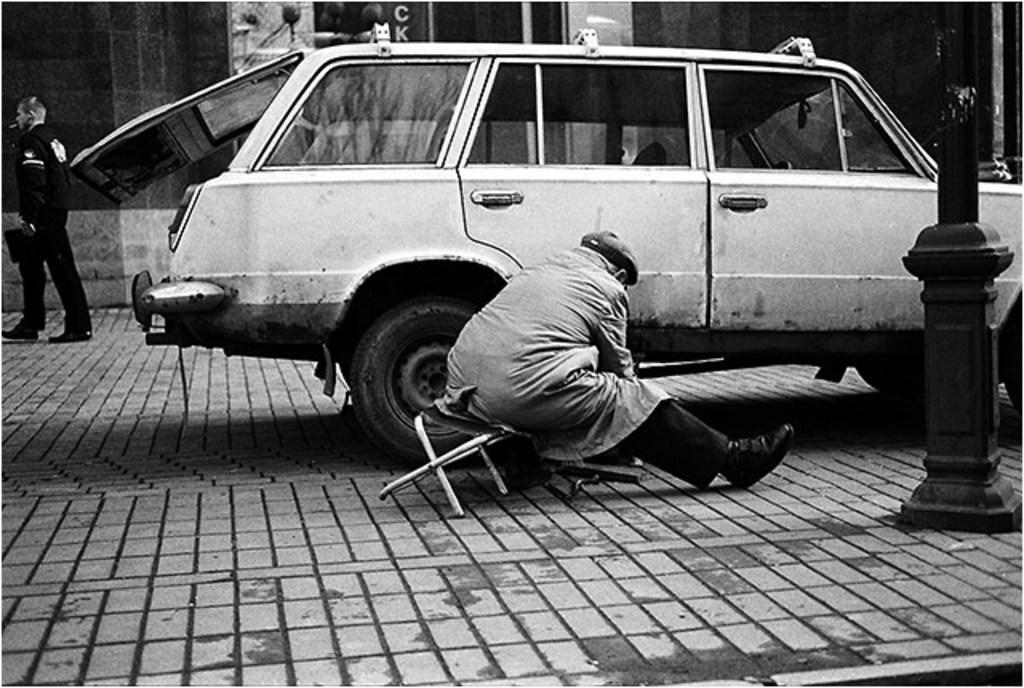What is the color scheme of the image? The image is black and white. What can be seen in the image besides the color scheme? There is a vehicle and a pole in the image. How many people are present in the image? There are two persons in the image. What is visible in the background of the image? There is a wall in the background of the image. Can you see a sack being carried by one of the persons in the image? There is no sack visible in the image, and no person is carrying one. Is there a bridge present in the image? No, there is no bridge in the image; only a vehicle, a pole, two persons, and a wall are visible. 